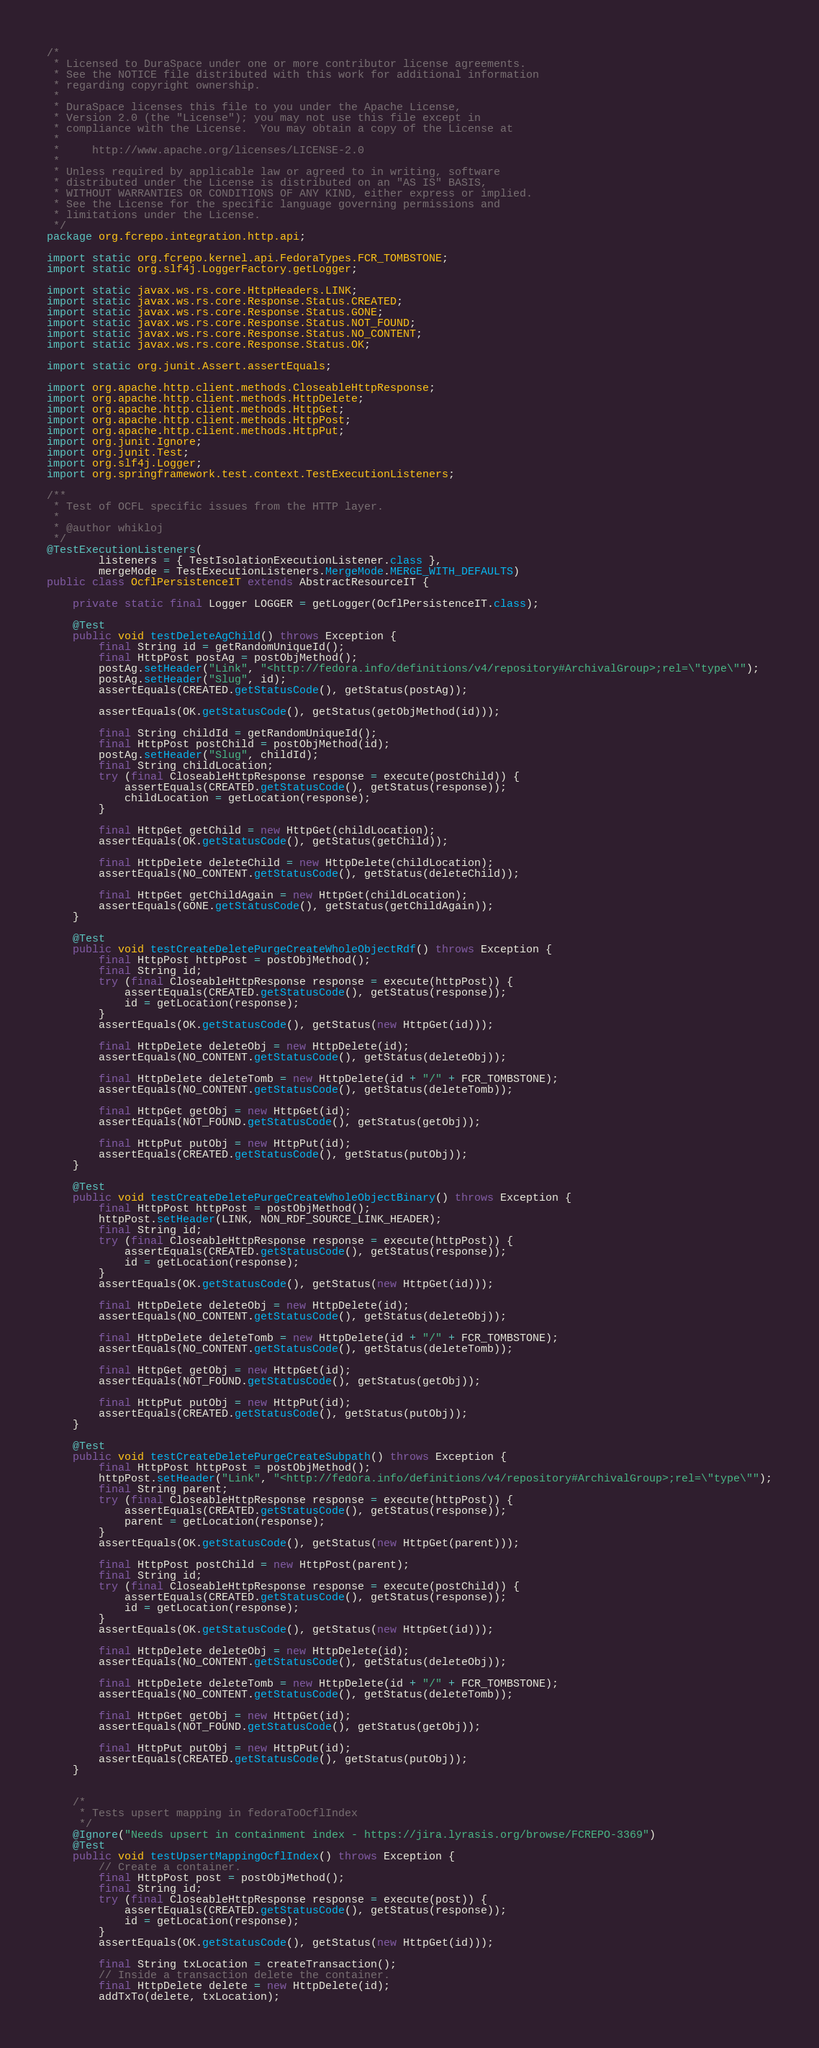Convert code to text. <code><loc_0><loc_0><loc_500><loc_500><_Java_>/*
 * Licensed to DuraSpace under one or more contributor license agreements.
 * See the NOTICE file distributed with this work for additional information
 * regarding copyright ownership.
 *
 * DuraSpace licenses this file to you under the Apache License,
 * Version 2.0 (the "License"); you may not use this file except in
 * compliance with the License.  You may obtain a copy of the License at
 *
 *     http://www.apache.org/licenses/LICENSE-2.0
 *
 * Unless required by applicable law or agreed to in writing, software
 * distributed under the License is distributed on an "AS IS" BASIS,
 * WITHOUT WARRANTIES OR CONDITIONS OF ANY KIND, either express or implied.
 * See the License for the specific language governing permissions and
 * limitations under the License.
 */
package org.fcrepo.integration.http.api;

import static org.fcrepo.kernel.api.FedoraTypes.FCR_TOMBSTONE;
import static org.slf4j.LoggerFactory.getLogger;

import static javax.ws.rs.core.HttpHeaders.LINK;
import static javax.ws.rs.core.Response.Status.CREATED;
import static javax.ws.rs.core.Response.Status.GONE;
import static javax.ws.rs.core.Response.Status.NOT_FOUND;
import static javax.ws.rs.core.Response.Status.NO_CONTENT;
import static javax.ws.rs.core.Response.Status.OK;

import static org.junit.Assert.assertEquals;

import org.apache.http.client.methods.CloseableHttpResponse;
import org.apache.http.client.methods.HttpDelete;
import org.apache.http.client.methods.HttpGet;
import org.apache.http.client.methods.HttpPost;
import org.apache.http.client.methods.HttpPut;
import org.junit.Ignore;
import org.junit.Test;
import org.slf4j.Logger;
import org.springframework.test.context.TestExecutionListeners;

/**
 * Test of OCFL specific issues from the HTTP layer.
 *
 * @author whikloj
 */
@TestExecutionListeners(
        listeners = { TestIsolationExecutionListener.class },
        mergeMode = TestExecutionListeners.MergeMode.MERGE_WITH_DEFAULTS)
public class OcflPersistenceIT extends AbstractResourceIT {

    private static final Logger LOGGER = getLogger(OcflPersistenceIT.class);

    @Test
    public void testDeleteAgChild() throws Exception {
        final String id = getRandomUniqueId();
        final HttpPost postAg = postObjMethod();
        postAg.setHeader("Link", "<http://fedora.info/definitions/v4/repository#ArchivalGroup>;rel=\"type\"");
        postAg.setHeader("Slug", id);
        assertEquals(CREATED.getStatusCode(), getStatus(postAg));

        assertEquals(OK.getStatusCode(), getStatus(getObjMethod(id)));

        final String childId = getRandomUniqueId();
        final HttpPost postChild = postObjMethod(id);
        postAg.setHeader("Slug", childId);
        final String childLocation;
        try (final CloseableHttpResponse response = execute(postChild)) {
            assertEquals(CREATED.getStatusCode(), getStatus(response));
            childLocation = getLocation(response);
        }

        final HttpGet getChild = new HttpGet(childLocation);
        assertEquals(OK.getStatusCode(), getStatus(getChild));

        final HttpDelete deleteChild = new HttpDelete(childLocation);
        assertEquals(NO_CONTENT.getStatusCode(), getStatus(deleteChild));

        final HttpGet getChildAgain = new HttpGet(childLocation);
        assertEquals(GONE.getStatusCode(), getStatus(getChildAgain));
    }

    @Test
    public void testCreateDeletePurgeCreateWholeObjectRdf() throws Exception {
        final HttpPost httpPost = postObjMethod();
        final String id;
        try (final CloseableHttpResponse response = execute(httpPost)) {
            assertEquals(CREATED.getStatusCode(), getStatus(response));
            id = getLocation(response);
        }
        assertEquals(OK.getStatusCode(), getStatus(new HttpGet(id)));

        final HttpDelete deleteObj = new HttpDelete(id);
        assertEquals(NO_CONTENT.getStatusCode(), getStatus(deleteObj));

        final HttpDelete deleteTomb = new HttpDelete(id + "/" + FCR_TOMBSTONE);
        assertEquals(NO_CONTENT.getStatusCode(), getStatus(deleteTomb));

        final HttpGet getObj = new HttpGet(id);
        assertEquals(NOT_FOUND.getStatusCode(), getStatus(getObj));

        final HttpPut putObj = new HttpPut(id);
        assertEquals(CREATED.getStatusCode(), getStatus(putObj));
    }

    @Test
    public void testCreateDeletePurgeCreateWholeObjectBinary() throws Exception {
        final HttpPost httpPost = postObjMethod();
        httpPost.setHeader(LINK, NON_RDF_SOURCE_LINK_HEADER);
        final String id;
        try (final CloseableHttpResponse response = execute(httpPost)) {
            assertEquals(CREATED.getStatusCode(), getStatus(response));
            id = getLocation(response);
        }
        assertEquals(OK.getStatusCode(), getStatus(new HttpGet(id)));

        final HttpDelete deleteObj = new HttpDelete(id);
        assertEquals(NO_CONTENT.getStatusCode(), getStatus(deleteObj));

        final HttpDelete deleteTomb = new HttpDelete(id + "/" + FCR_TOMBSTONE);
        assertEquals(NO_CONTENT.getStatusCode(), getStatus(deleteTomb));

        final HttpGet getObj = new HttpGet(id);
        assertEquals(NOT_FOUND.getStatusCode(), getStatus(getObj));

        final HttpPut putObj = new HttpPut(id);
        assertEquals(CREATED.getStatusCode(), getStatus(putObj));
    }

    @Test
    public void testCreateDeletePurgeCreateSubpath() throws Exception {
        final HttpPost httpPost = postObjMethod();
        httpPost.setHeader("Link", "<http://fedora.info/definitions/v4/repository#ArchivalGroup>;rel=\"type\"");
        final String parent;
        try (final CloseableHttpResponse response = execute(httpPost)) {
            assertEquals(CREATED.getStatusCode(), getStatus(response));
            parent = getLocation(response);
        }
        assertEquals(OK.getStatusCode(), getStatus(new HttpGet(parent)));

        final HttpPost postChild = new HttpPost(parent);
        final String id;
        try (final CloseableHttpResponse response = execute(postChild)) {
            assertEquals(CREATED.getStatusCode(), getStatus(response));
            id = getLocation(response);
        }
        assertEquals(OK.getStatusCode(), getStatus(new HttpGet(id)));

        final HttpDelete deleteObj = new HttpDelete(id);
        assertEquals(NO_CONTENT.getStatusCode(), getStatus(deleteObj));

        final HttpDelete deleteTomb = new HttpDelete(id + "/" + FCR_TOMBSTONE);
        assertEquals(NO_CONTENT.getStatusCode(), getStatus(deleteTomb));

        final HttpGet getObj = new HttpGet(id);
        assertEquals(NOT_FOUND.getStatusCode(), getStatus(getObj));

        final HttpPut putObj = new HttpPut(id);
        assertEquals(CREATED.getStatusCode(), getStatus(putObj));
    }


    /*
     * Tests upsert mapping in fedoraToOcflIndex
     */
    @Ignore("Needs upsert in containment index - https://jira.lyrasis.org/browse/FCREPO-3369")
    @Test
    public void testUpsertMappingOcflIndex() throws Exception {
        // Create a container.
        final HttpPost post = postObjMethod();
        final String id;
        try (final CloseableHttpResponse response = execute(post)) {
            assertEquals(CREATED.getStatusCode(), getStatus(response));
            id = getLocation(response);
        }
        assertEquals(OK.getStatusCode(), getStatus(new HttpGet(id)));

        final String txLocation = createTransaction();
        // Inside a transaction delete the container.
        final HttpDelete delete = new HttpDelete(id);
        addTxTo(delete, txLocation);</code> 